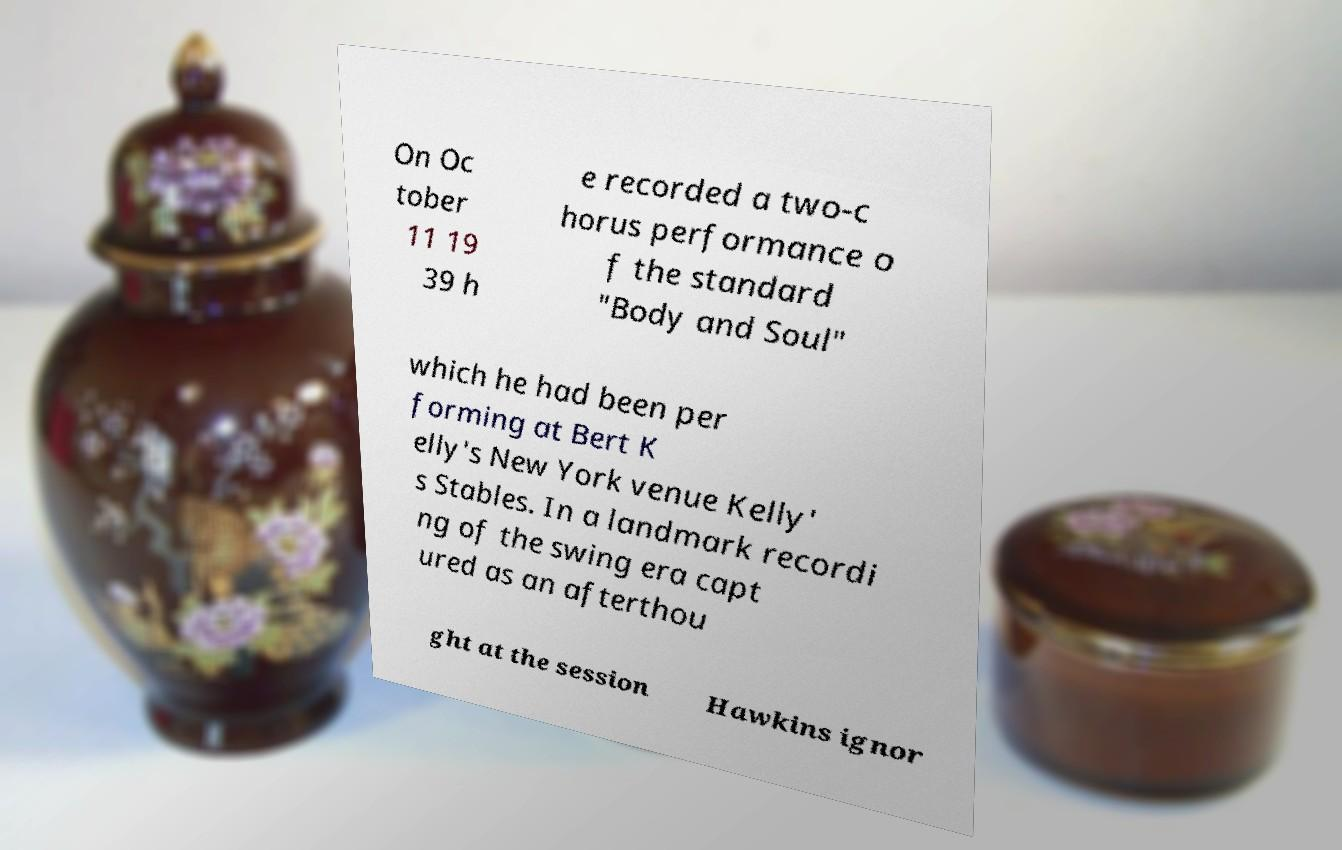What messages or text are displayed in this image? I need them in a readable, typed format. On Oc tober 11 19 39 h e recorded a two-c horus performance o f the standard "Body and Soul" which he had been per forming at Bert K elly's New York venue Kelly' s Stables. In a landmark recordi ng of the swing era capt ured as an afterthou ght at the session Hawkins ignor 